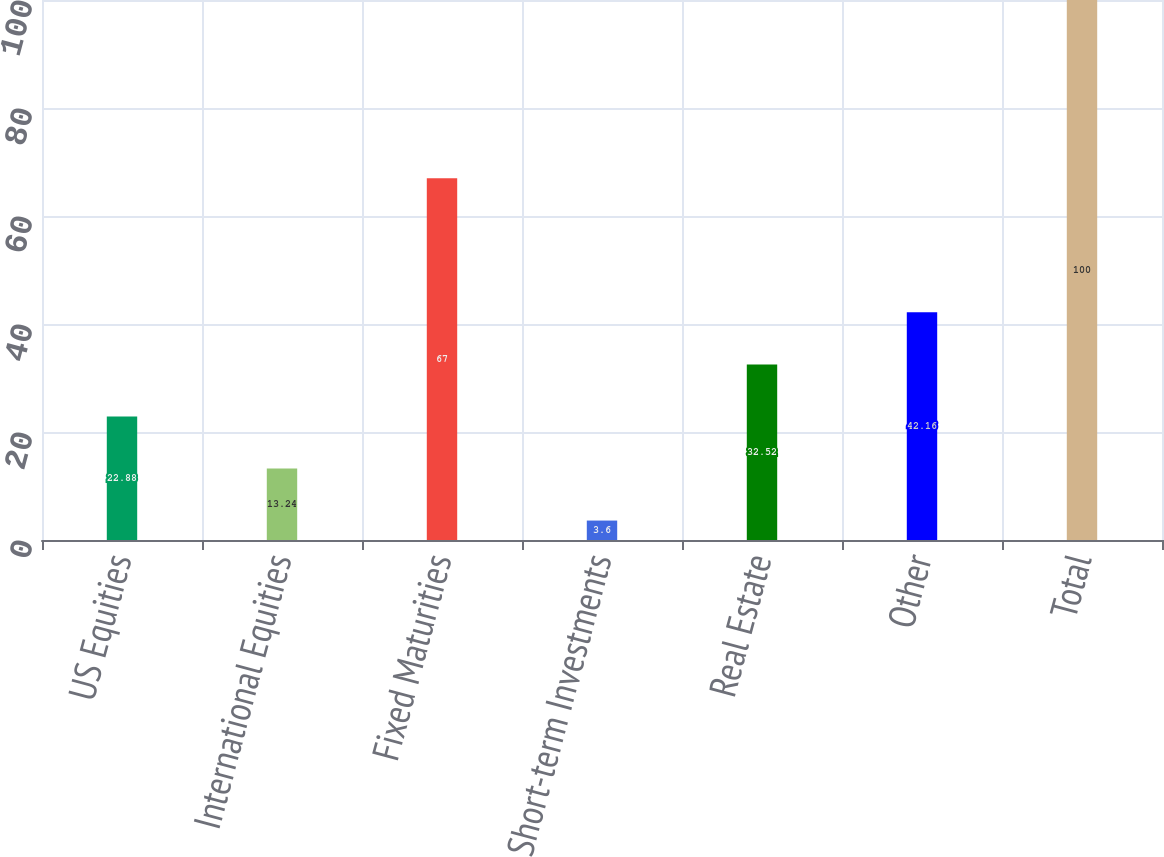Convert chart to OTSL. <chart><loc_0><loc_0><loc_500><loc_500><bar_chart><fcel>US Equities<fcel>International Equities<fcel>Fixed Maturities<fcel>Short-term Investments<fcel>Real Estate<fcel>Other<fcel>Total<nl><fcel>22.88<fcel>13.24<fcel>67<fcel>3.6<fcel>32.52<fcel>42.16<fcel>100<nl></chart> 